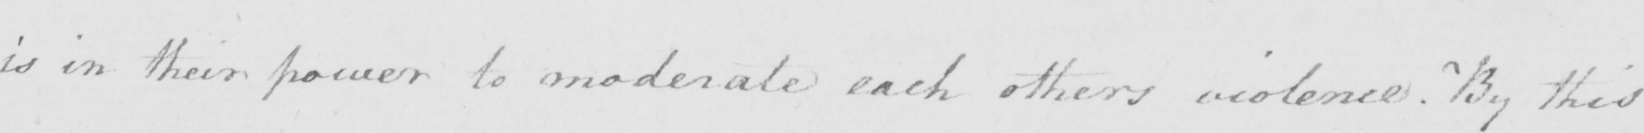Can you tell me what this handwritten text says? is in their power to moderate each others violence. By this 